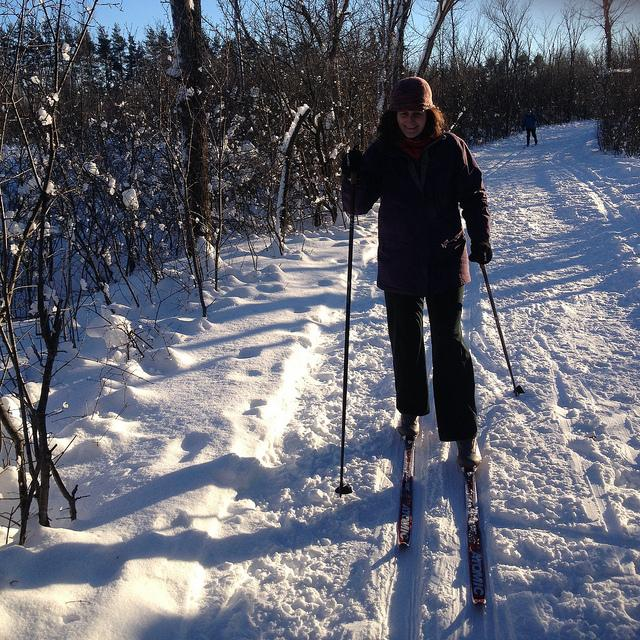What is making the thin lines in the snow? skis 